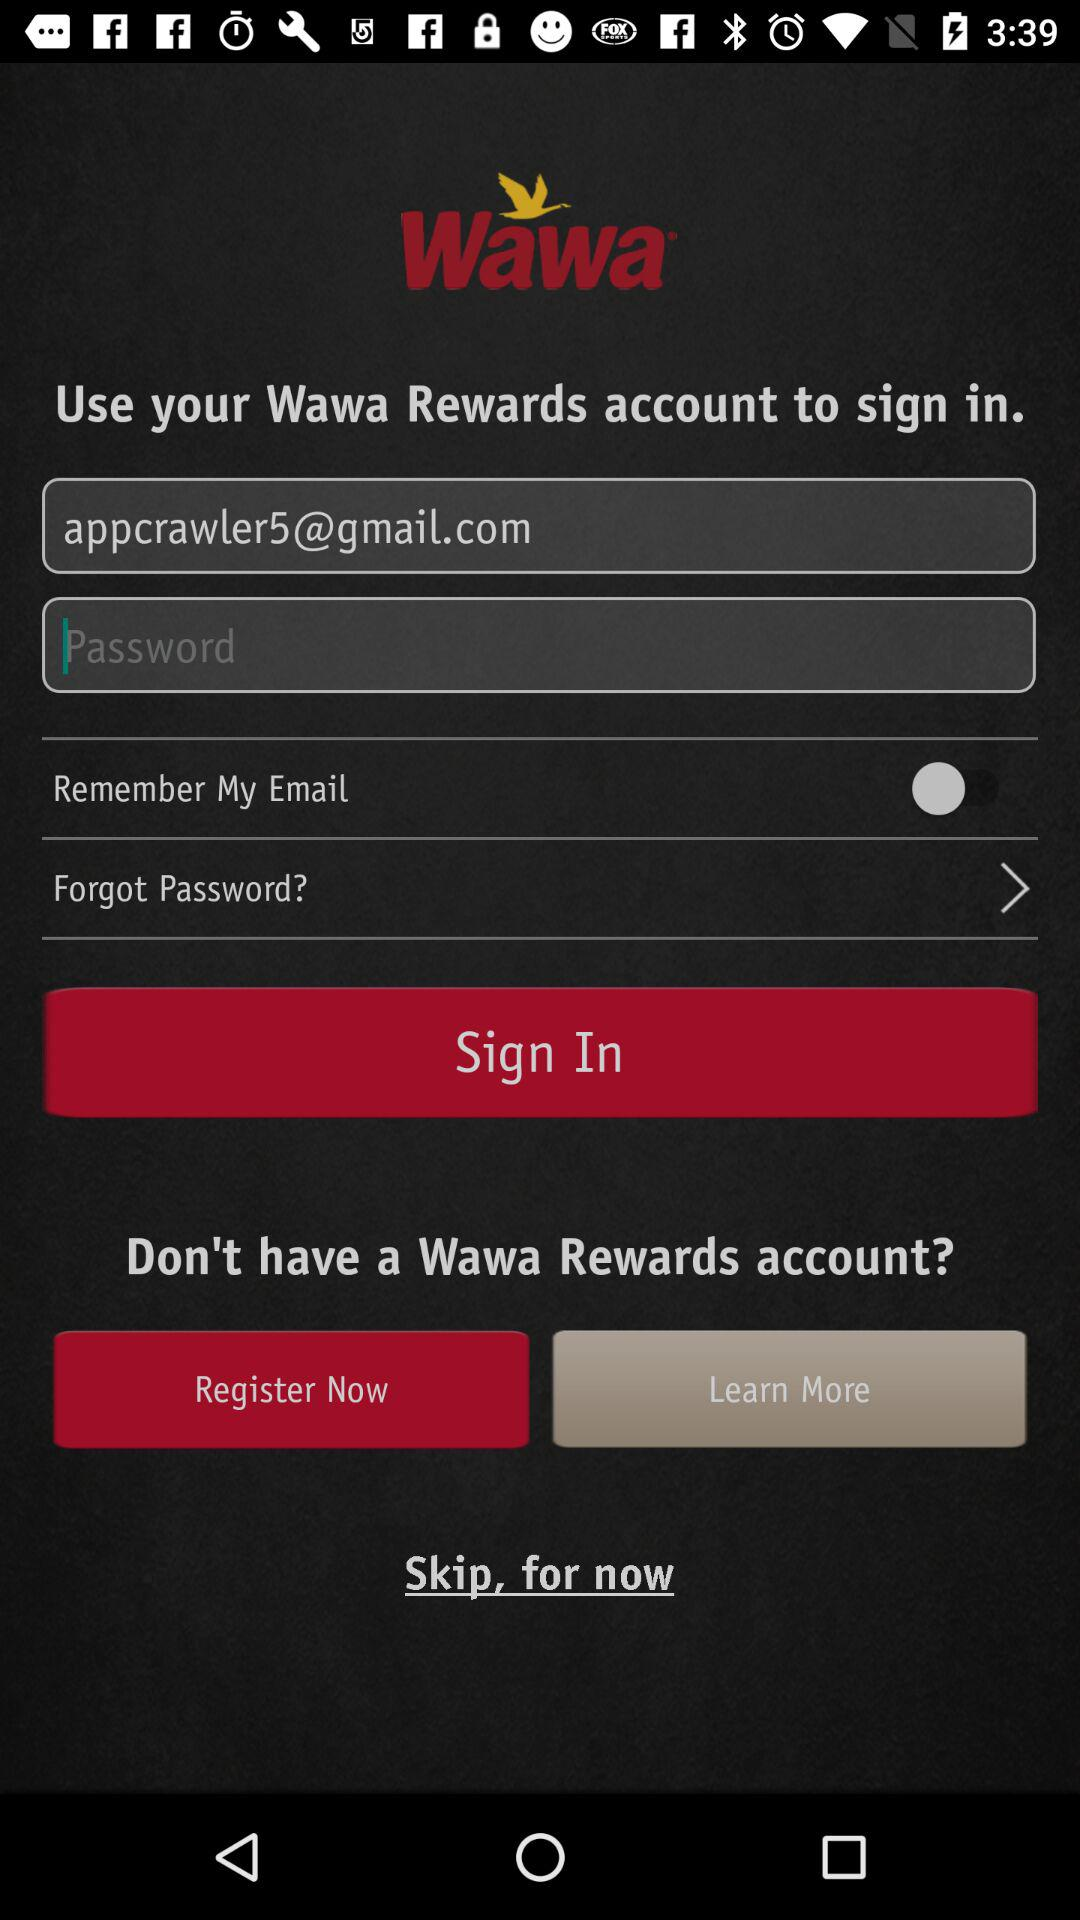What is the email address? The email address is appcrawler5@gmail.com. 